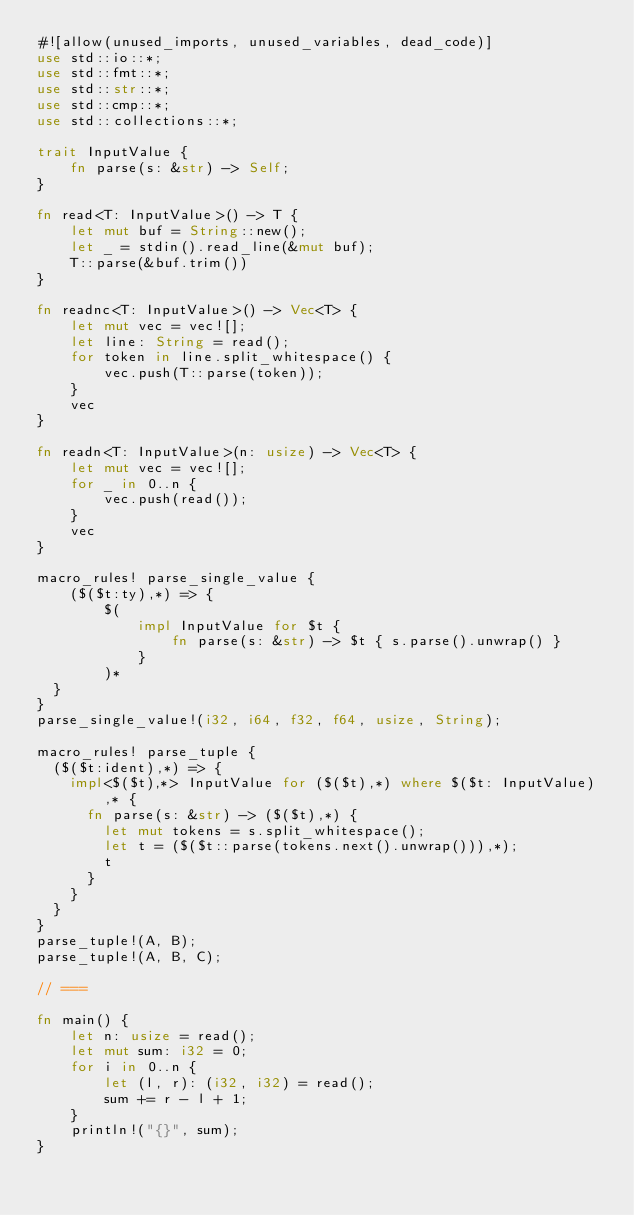<code> <loc_0><loc_0><loc_500><loc_500><_Rust_>#![allow(unused_imports, unused_variables, dead_code)]
use std::io::*;
use std::fmt::*;
use std::str::*;
use std::cmp::*;
use std::collections::*;

trait InputValue {
    fn parse(s: &str) -> Self;
}

fn read<T: InputValue>() -> T {
    let mut buf = String::new();
    let _ = stdin().read_line(&mut buf);
    T::parse(&buf.trim())
}

fn readnc<T: InputValue>() -> Vec<T> {
    let mut vec = vec![];
    let line: String = read();
    for token in line.split_whitespace() {
        vec.push(T::parse(token));
    }
    vec
}

fn readn<T: InputValue>(n: usize) -> Vec<T> {
    let mut vec = vec![];
    for _ in 0..n {
        vec.push(read());
    }
    vec
}

macro_rules! parse_single_value {
    ($($t:ty),*) => {
        $(
            impl InputValue for $t {
                fn parse(s: &str) -> $t { s.parse().unwrap() }
            }
        )*
	}
}
parse_single_value!(i32, i64, f32, f64, usize, String);

macro_rules! parse_tuple {
	($($t:ident),*) => {
		impl<$($t),*> InputValue for ($($t),*) where $($t: InputValue),* {
			fn parse(s: &str) -> ($($t),*) {
				let mut tokens = s.split_whitespace();
				let t = ($($t::parse(tokens.next().unwrap())),*);
				t
			}
		}
	}
}
parse_tuple!(A, B);
parse_tuple!(A, B, C);

// ===

fn main() {
    let n: usize = read();
    let mut sum: i32 = 0;
    for i in 0..n {
        let (l, r): (i32, i32) = read();
        sum += r - l + 1;
    }
    println!("{}", sum);
}</code> 